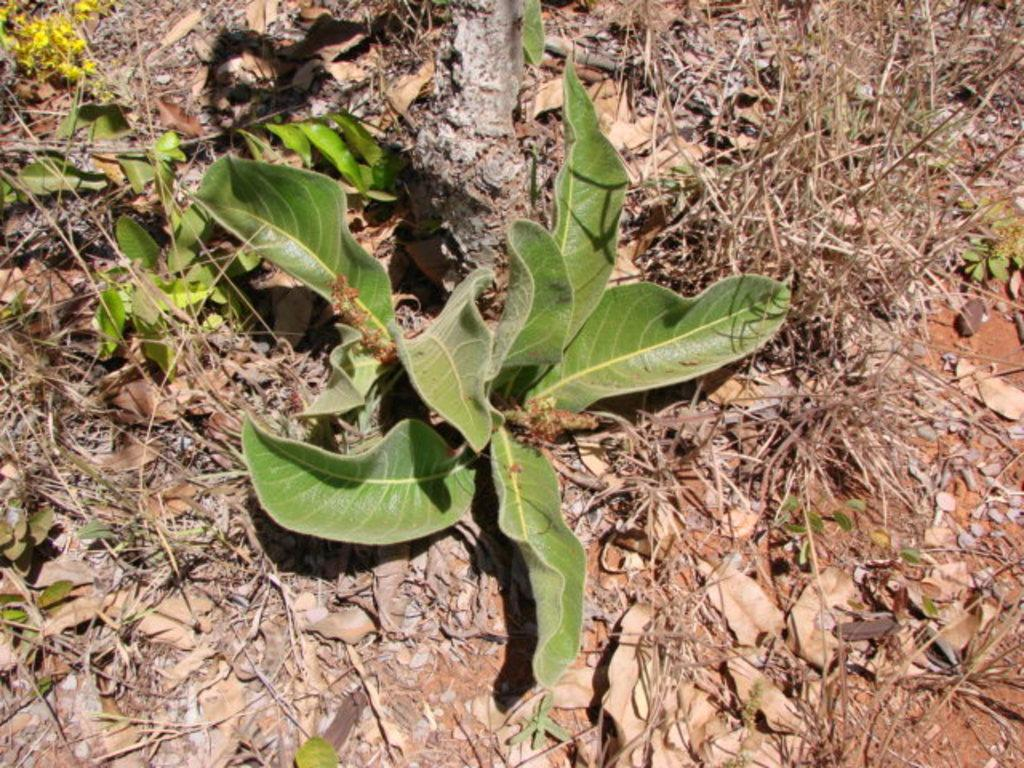What is present in the image? There is a plant in the image. Where is the plant located? The plant is on the ground. What is covering the ground in the image? The ground is covered with dry leaves. Can you see a goat grazing near the plant in the image? No, there is no goat present in the image. Is there an airport visible in the background of the image? No, there is no airport visible in the image. 